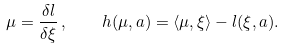Convert formula to latex. <formula><loc_0><loc_0><loc_500><loc_500>\mu = \frac { \delta l } { \delta \xi } \, , \quad h ( \mu , a ) = \langle \mu , \xi \rangle - l ( \xi , a ) .</formula> 